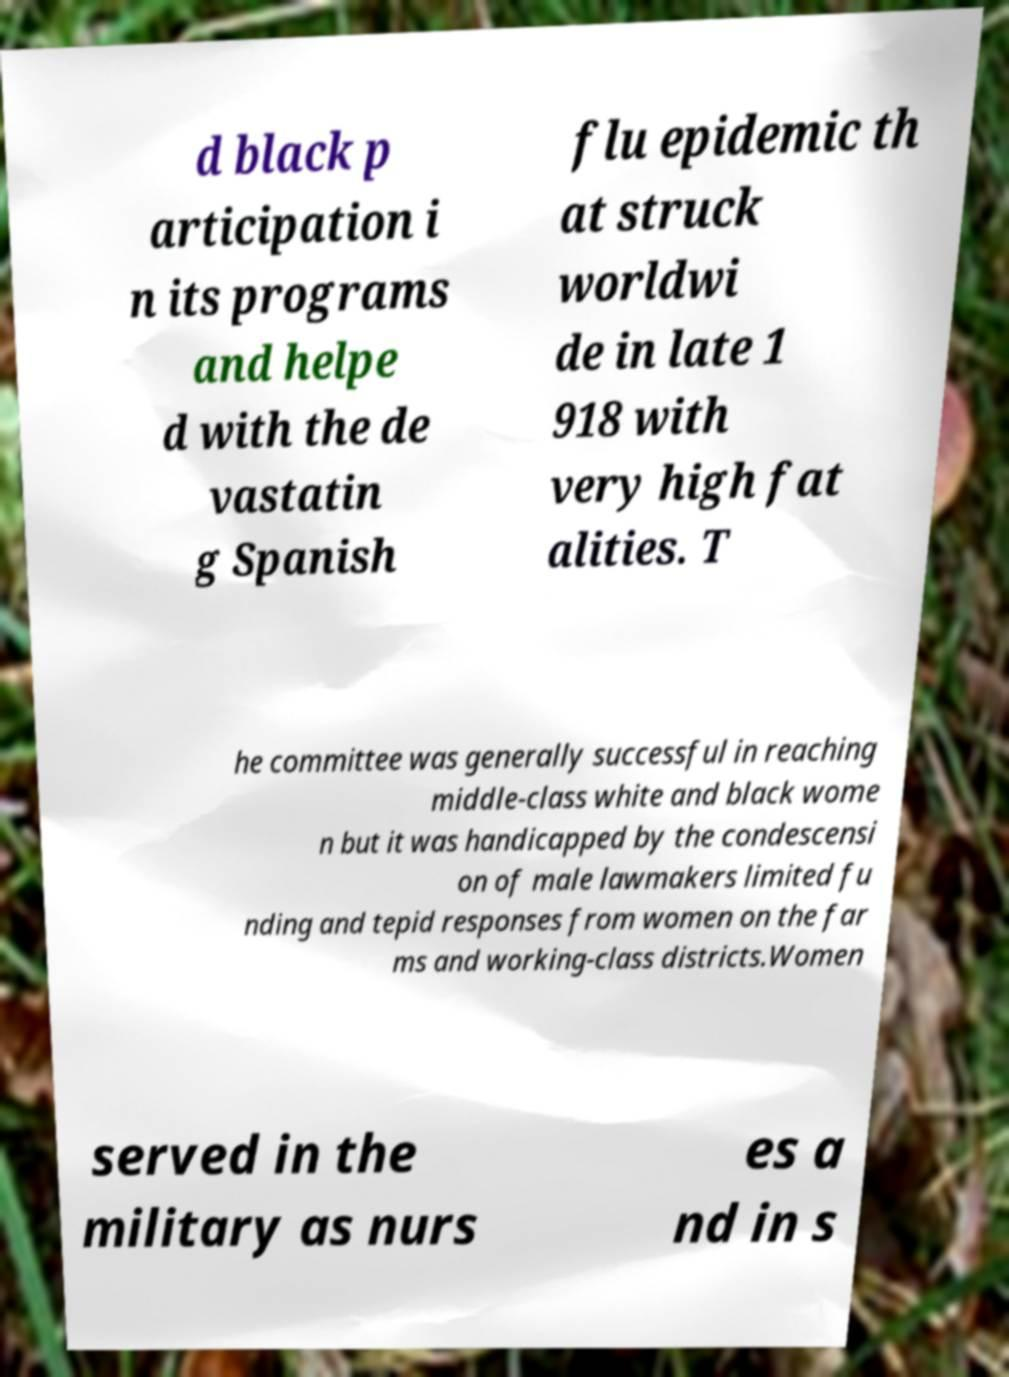What messages or text are displayed in this image? I need them in a readable, typed format. d black p articipation i n its programs and helpe d with the de vastatin g Spanish flu epidemic th at struck worldwi de in late 1 918 with very high fat alities. T he committee was generally successful in reaching middle-class white and black wome n but it was handicapped by the condescensi on of male lawmakers limited fu nding and tepid responses from women on the far ms and working-class districts.Women served in the military as nurs es a nd in s 